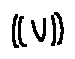Convert formula to latex. <formula><loc_0><loc_0><loc_500><loc_500>( ( V ) )</formula> 